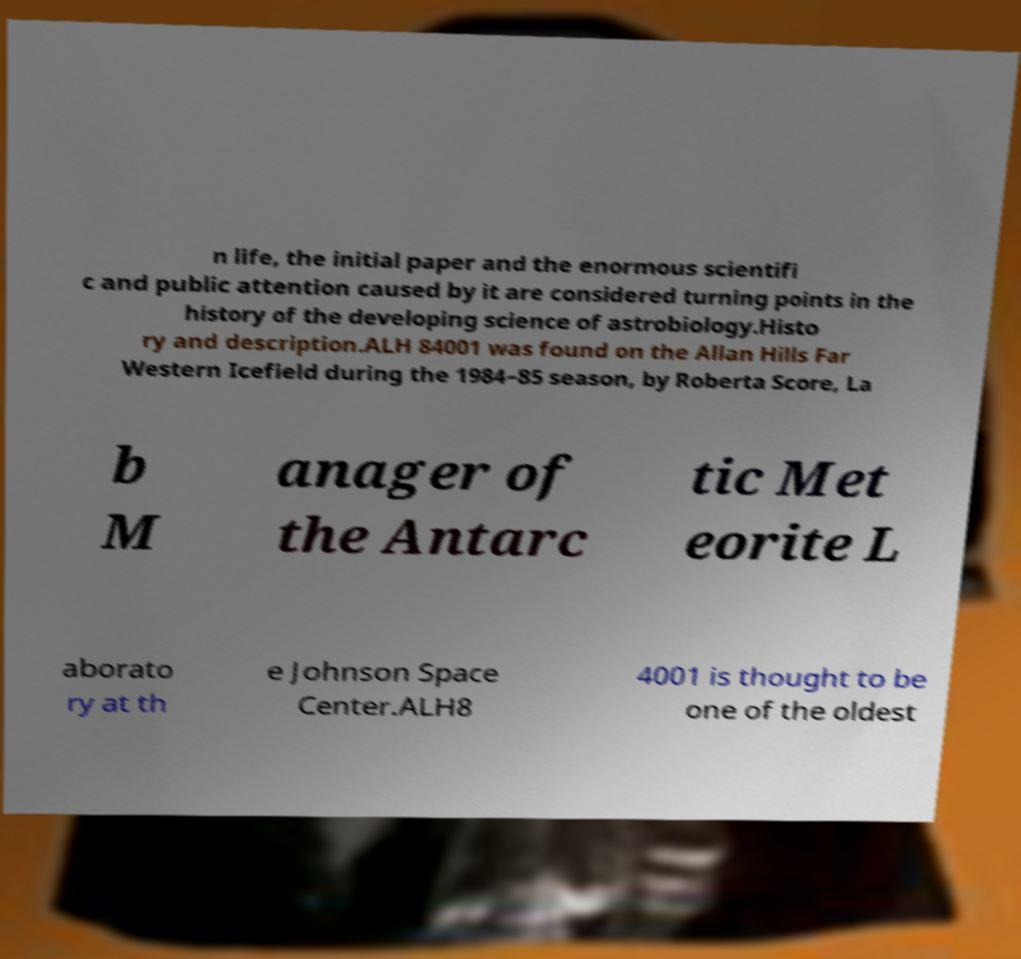Please identify and transcribe the text found in this image. n life, the initial paper and the enormous scientifi c and public attention caused by it are considered turning points in the history of the developing science of astrobiology.Histo ry and description.ALH 84001 was found on the Allan Hills Far Western Icefield during the 1984–85 season, by Roberta Score, La b M anager of the Antarc tic Met eorite L aborato ry at th e Johnson Space Center.ALH8 4001 is thought to be one of the oldest 